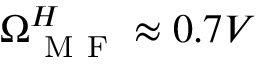<formula> <loc_0><loc_0><loc_500><loc_500>\Omega _ { M F } ^ { H } \approx 0 . 7 V</formula> 